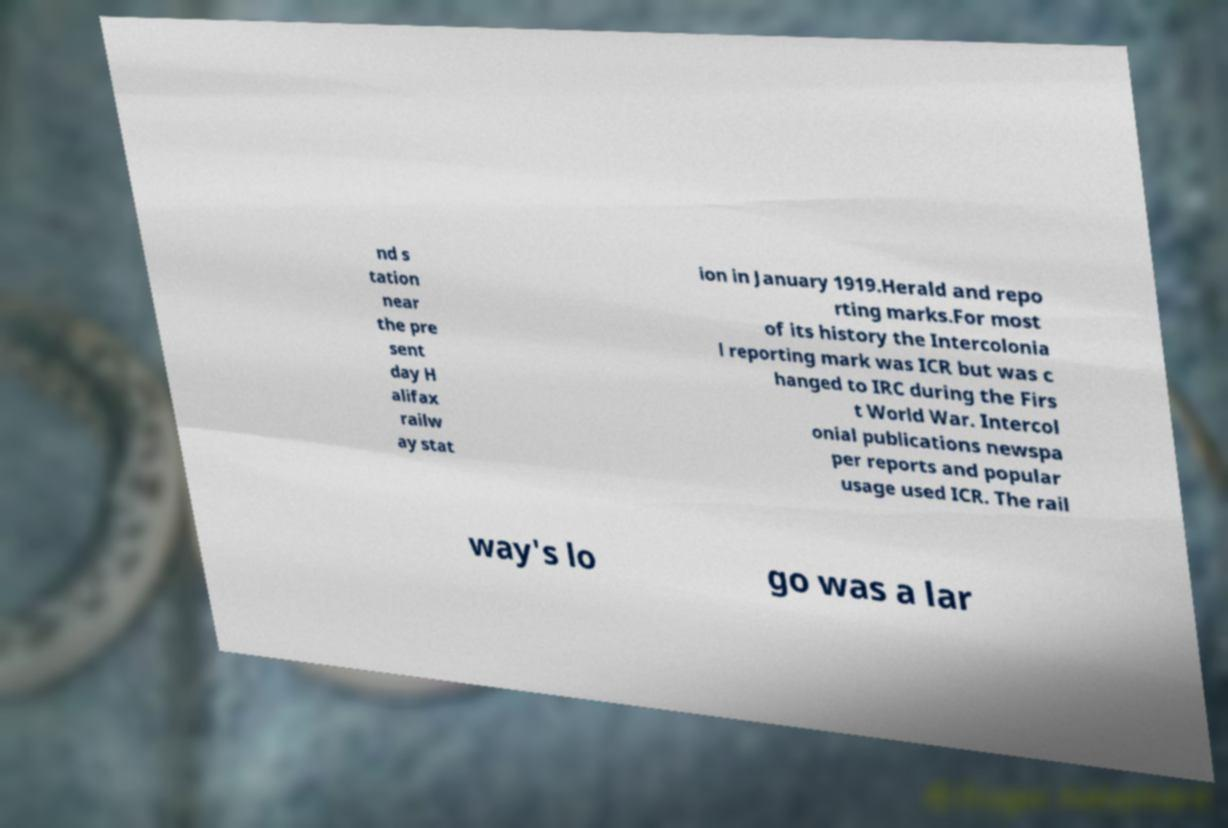There's text embedded in this image that I need extracted. Can you transcribe it verbatim? nd s tation near the pre sent day H alifax railw ay stat ion in January 1919.Herald and repo rting marks.For most of its history the Intercolonia l reporting mark was ICR but was c hanged to IRC during the Firs t World War. Intercol onial publications newspa per reports and popular usage used ICR. The rail way's lo go was a lar 